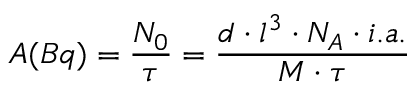Convert formula to latex. <formula><loc_0><loc_0><loc_500><loc_500>A ( B q ) = \frac { N _ { 0 } } { \tau } = \frac { d \cdot l ^ { 3 } \cdot N _ { A } \cdot i . a . } { M \cdot \tau }</formula> 